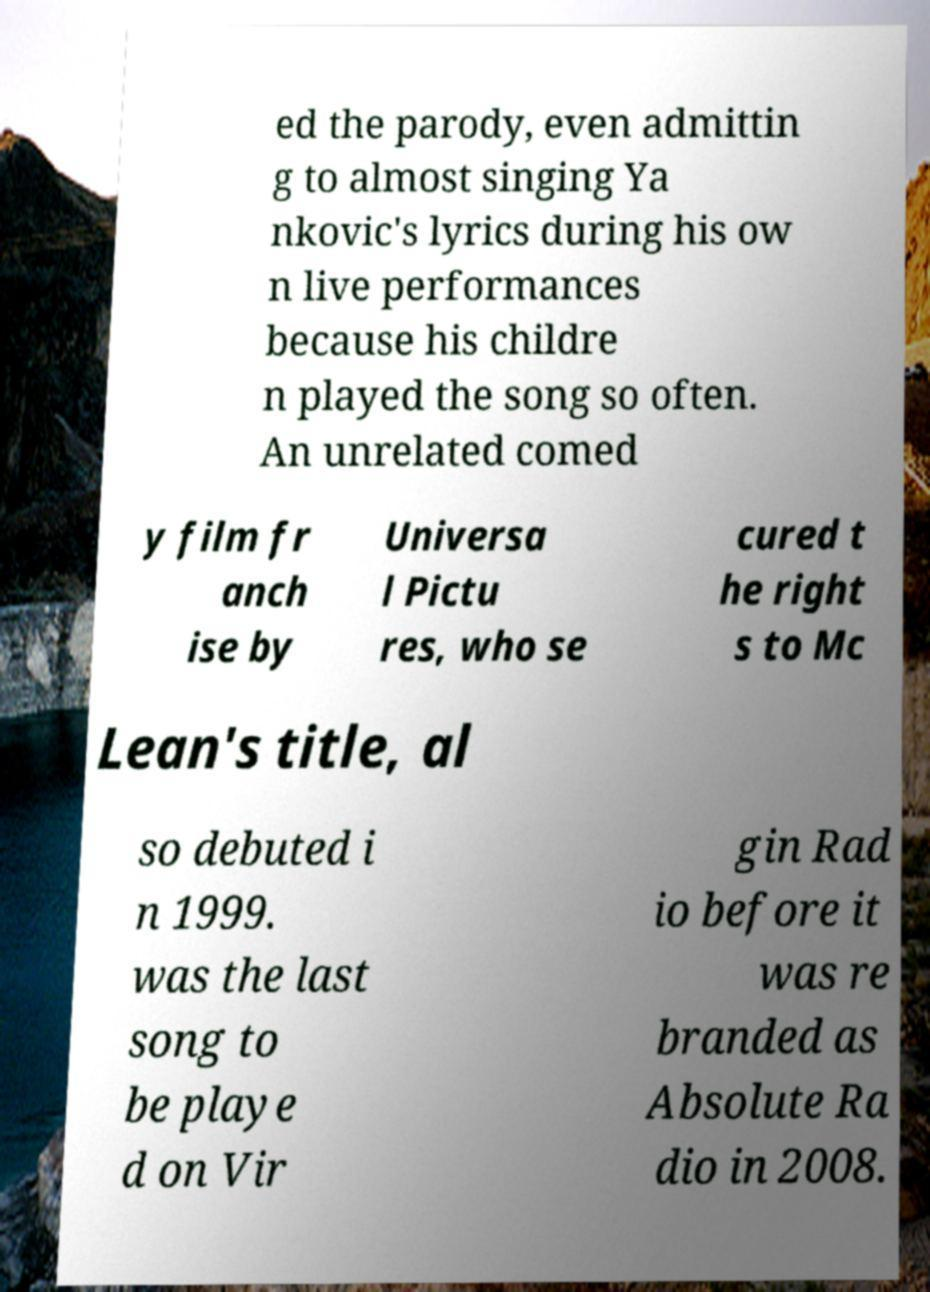Can you accurately transcribe the text from the provided image for me? ed the parody, even admittin g to almost singing Ya nkovic's lyrics during his ow n live performances because his childre n played the song so often. An unrelated comed y film fr anch ise by Universa l Pictu res, who se cured t he right s to Mc Lean's title, al so debuted i n 1999. was the last song to be playe d on Vir gin Rad io before it was re branded as Absolute Ra dio in 2008. 